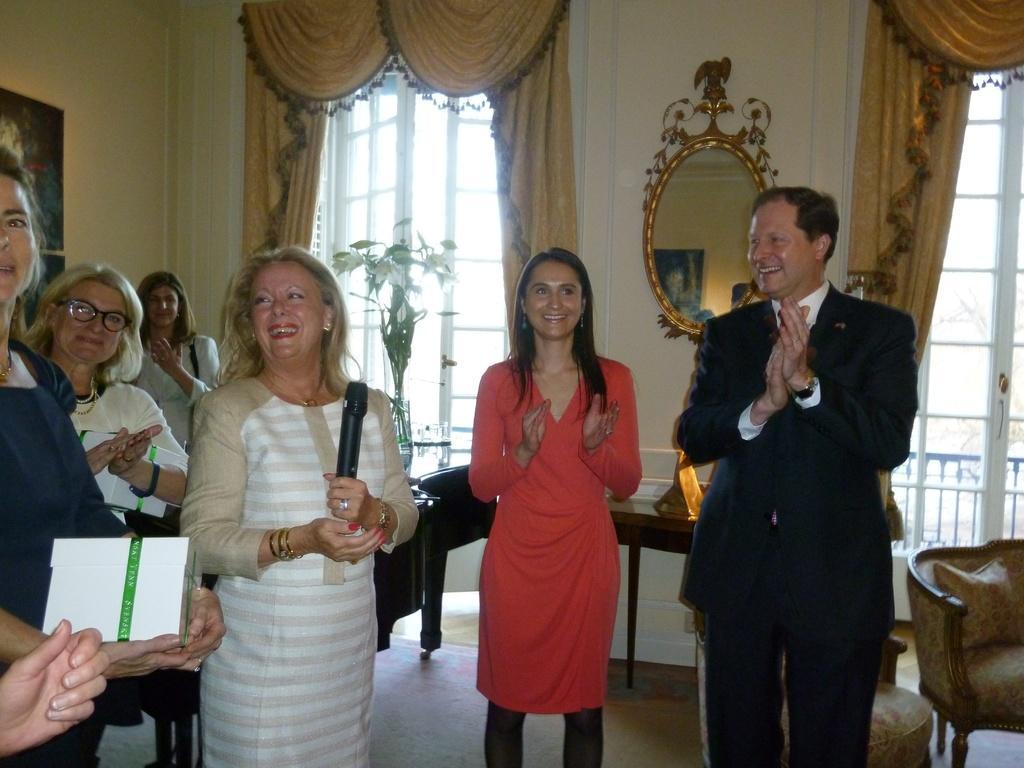Could you give a brief overview of what you see in this image? In this image we can see a few people standing on the floor and they are clapping. Here we can see a woman holding the microphone in her hands. Here we can see the smile on their faces. Here we can see the chairs on the floor on the bottom right side. Here we can see a table on the floor. Here we can see the mirror on the wall. In the background, we can see the glass windows and curtains. 